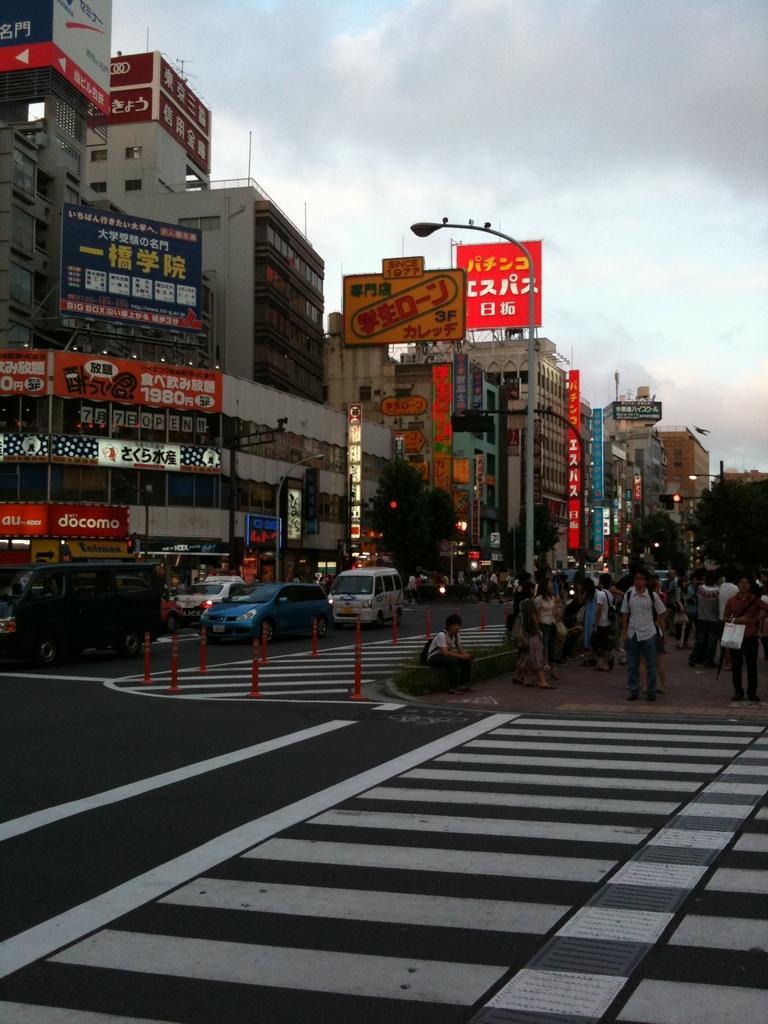In one or two sentences, can you explain what this image depicts? In this picture we can see some poles, vehicles and a few white lines on the road. There are some people standing and a person is sitting on the right side. We can see a few boards on the buildings. There are street lights and trees are visible in the background. Sky is cloudy. 